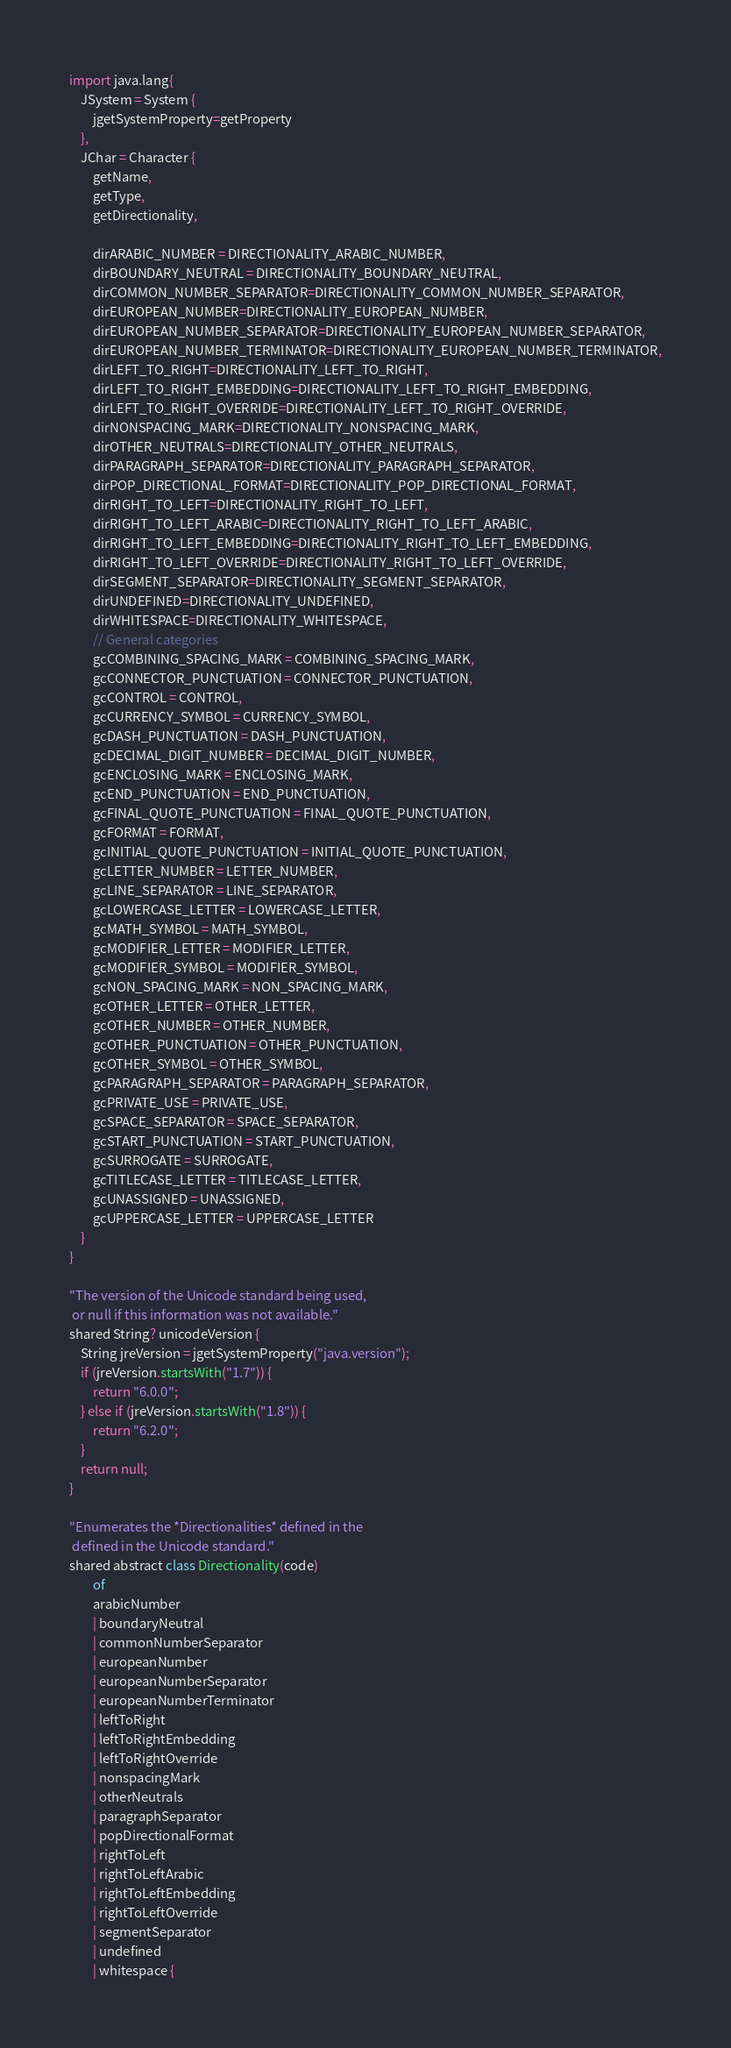<code> <loc_0><loc_0><loc_500><loc_500><_Ceylon_>import java.lang{
    JSystem = System { 
        jgetSystemProperty=getProperty 
    },
    JChar = Character { 
        getName,
        getType,
        getDirectionality,
        
        dirARABIC_NUMBER = DIRECTIONALITY_ARABIC_NUMBER,
        dirBOUNDARY_NEUTRAL = DIRECTIONALITY_BOUNDARY_NEUTRAL,
        dirCOMMON_NUMBER_SEPARATOR=DIRECTIONALITY_COMMON_NUMBER_SEPARATOR,
        dirEUROPEAN_NUMBER=DIRECTIONALITY_EUROPEAN_NUMBER,
        dirEUROPEAN_NUMBER_SEPARATOR=DIRECTIONALITY_EUROPEAN_NUMBER_SEPARATOR,
        dirEUROPEAN_NUMBER_TERMINATOR=DIRECTIONALITY_EUROPEAN_NUMBER_TERMINATOR,
        dirLEFT_TO_RIGHT=DIRECTIONALITY_LEFT_TO_RIGHT,
        dirLEFT_TO_RIGHT_EMBEDDING=DIRECTIONALITY_LEFT_TO_RIGHT_EMBEDDING,
        dirLEFT_TO_RIGHT_OVERRIDE=DIRECTIONALITY_LEFT_TO_RIGHT_OVERRIDE,
        dirNONSPACING_MARK=DIRECTIONALITY_NONSPACING_MARK,
        dirOTHER_NEUTRALS=DIRECTIONALITY_OTHER_NEUTRALS,
        dirPARAGRAPH_SEPARATOR=DIRECTIONALITY_PARAGRAPH_SEPARATOR,
        dirPOP_DIRECTIONAL_FORMAT=DIRECTIONALITY_POP_DIRECTIONAL_FORMAT,
        dirRIGHT_TO_LEFT=DIRECTIONALITY_RIGHT_TO_LEFT,
        dirRIGHT_TO_LEFT_ARABIC=DIRECTIONALITY_RIGHT_TO_LEFT_ARABIC,
        dirRIGHT_TO_LEFT_EMBEDDING=DIRECTIONALITY_RIGHT_TO_LEFT_EMBEDDING,
        dirRIGHT_TO_LEFT_OVERRIDE=DIRECTIONALITY_RIGHT_TO_LEFT_OVERRIDE,
        dirSEGMENT_SEPARATOR=DIRECTIONALITY_SEGMENT_SEPARATOR,
        dirUNDEFINED=DIRECTIONALITY_UNDEFINED,
        dirWHITESPACE=DIRECTIONALITY_WHITESPACE,
        // General categories
        gcCOMBINING_SPACING_MARK = COMBINING_SPACING_MARK,
        gcCONNECTOR_PUNCTUATION = CONNECTOR_PUNCTUATION,
        gcCONTROL = CONTROL,
        gcCURRENCY_SYMBOL = CURRENCY_SYMBOL,
        gcDASH_PUNCTUATION = DASH_PUNCTUATION,
        gcDECIMAL_DIGIT_NUMBER = DECIMAL_DIGIT_NUMBER,
        gcENCLOSING_MARK = ENCLOSING_MARK,
        gcEND_PUNCTUATION = END_PUNCTUATION,
        gcFINAL_QUOTE_PUNCTUATION = FINAL_QUOTE_PUNCTUATION,
        gcFORMAT = FORMAT,
        gcINITIAL_QUOTE_PUNCTUATION = INITIAL_QUOTE_PUNCTUATION,
        gcLETTER_NUMBER = LETTER_NUMBER,
        gcLINE_SEPARATOR = LINE_SEPARATOR,
        gcLOWERCASE_LETTER = LOWERCASE_LETTER,
        gcMATH_SYMBOL = MATH_SYMBOL,
        gcMODIFIER_LETTER = MODIFIER_LETTER,
        gcMODIFIER_SYMBOL = MODIFIER_SYMBOL,
        gcNON_SPACING_MARK = NON_SPACING_MARK,
        gcOTHER_LETTER = OTHER_LETTER,
        gcOTHER_NUMBER = OTHER_NUMBER,
        gcOTHER_PUNCTUATION = OTHER_PUNCTUATION,
        gcOTHER_SYMBOL = OTHER_SYMBOL,
        gcPARAGRAPH_SEPARATOR = PARAGRAPH_SEPARATOR,
        gcPRIVATE_USE = PRIVATE_USE,
        gcSPACE_SEPARATOR = SPACE_SEPARATOR,
        gcSTART_PUNCTUATION = START_PUNCTUATION,
        gcSURROGATE = SURROGATE,
        gcTITLECASE_LETTER = TITLECASE_LETTER,
        gcUNASSIGNED = UNASSIGNED,
        gcUPPERCASE_LETTER = UPPERCASE_LETTER
    }
}

"The version of the Unicode standard being used, 
 or null if this information was not available."
shared String? unicodeVersion {
    String jreVersion = jgetSystemProperty("java.version");
    if (jreVersion.startsWith("1.7")) {
        return "6.0.0";
    } else if (jreVersion.startsWith("1.8")) {
        return "6.2.0";
    }
    return null;
}

"Enumerates the *Directionalities* defined in the 
 defined in the Unicode standard."
shared abstract class Directionality(code)
        of
        arabicNumber 
        | boundaryNeutral
        | commonNumberSeparator
        | europeanNumber
        | europeanNumberSeparator
        | europeanNumberTerminator
        | leftToRight
        | leftToRightEmbedding
        | leftToRightOverride
        | nonspacingMark
        | otherNeutrals
        | paragraphSeparator
        | popDirectionalFormat
        | rightToLeft
        | rightToLeftArabic
        | rightToLeftEmbedding
        | rightToLeftOverride
        | segmentSeparator
        | undefined
        | whitespace {</code> 